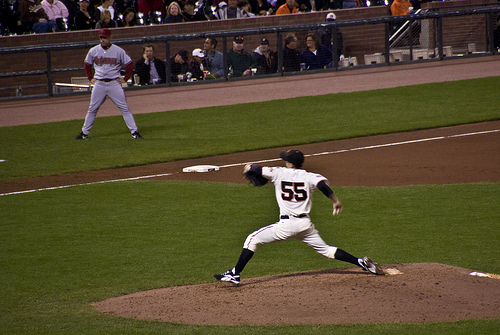What is on the pitcher? The pitcher is wearing a hat as part of his uniform. 